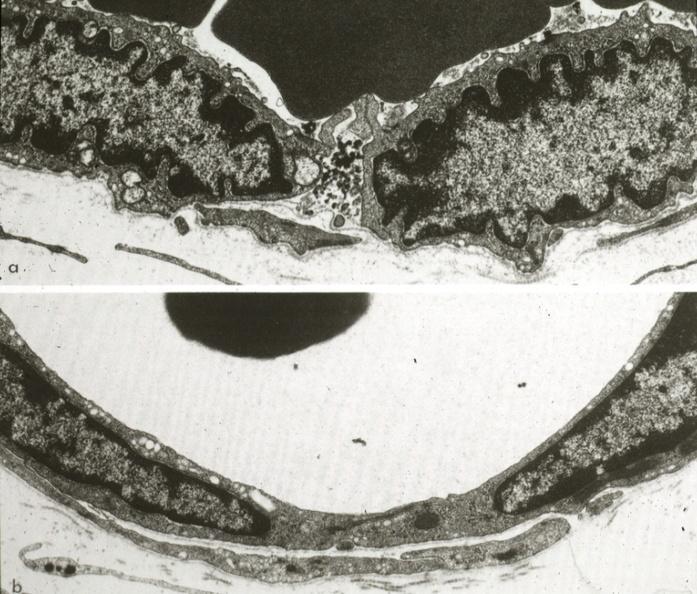s vasculature present?
Answer the question using a single word or phrase. Yes 